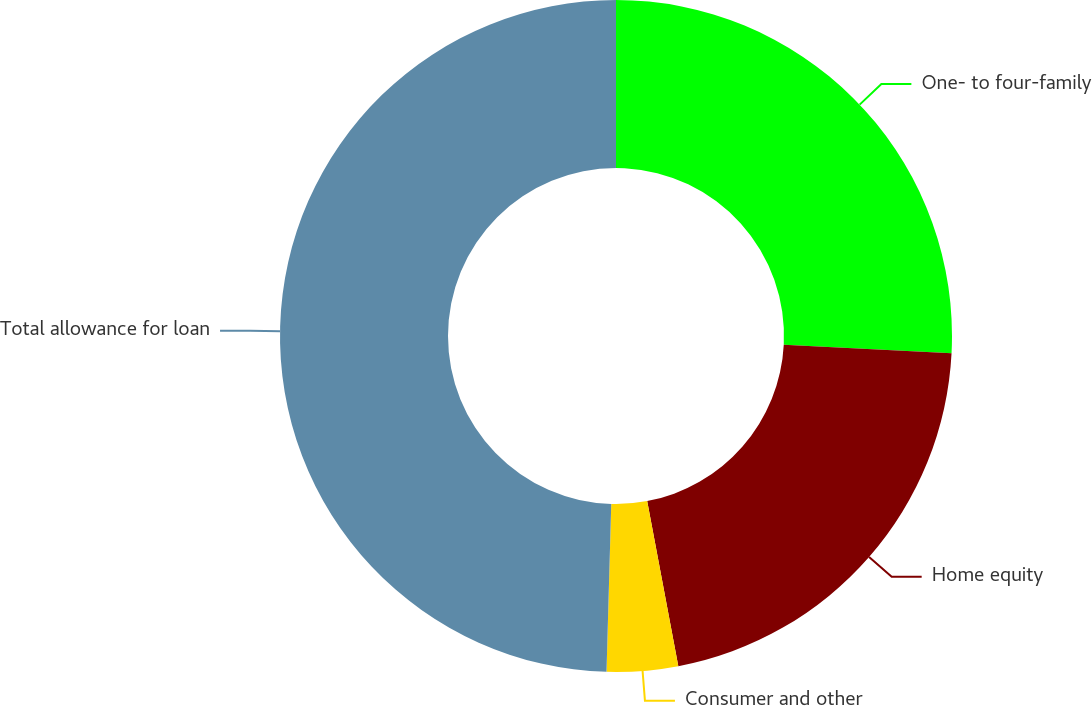Convert chart. <chart><loc_0><loc_0><loc_500><loc_500><pie_chart><fcel>One- to four-family<fcel>Home equity<fcel>Consumer and other<fcel>Total allowance for loan<nl><fcel>25.82%<fcel>21.21%<fcel>3.42%<fcel>49.55%<nl></chart> 